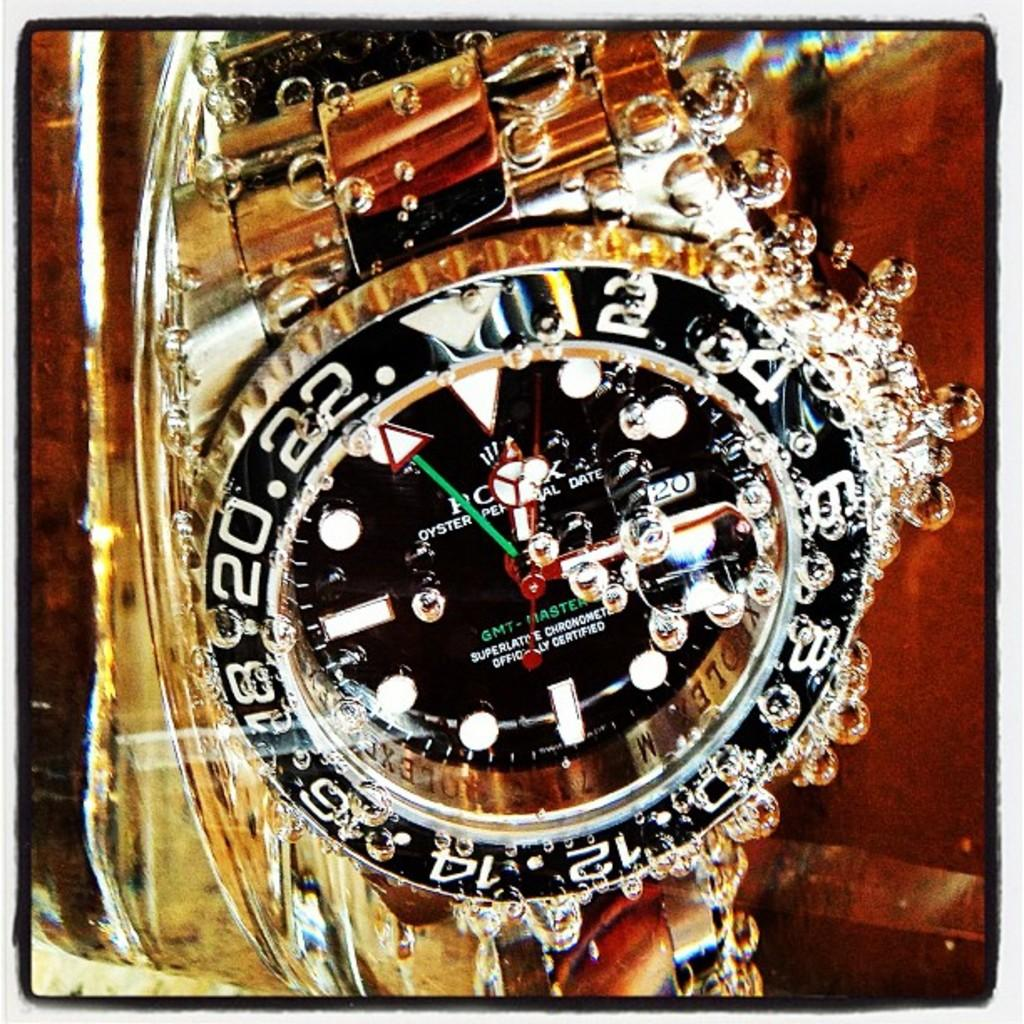<image>
Summarize the visual content of the image. A gold GMT-Master Rolex watch is under water. 